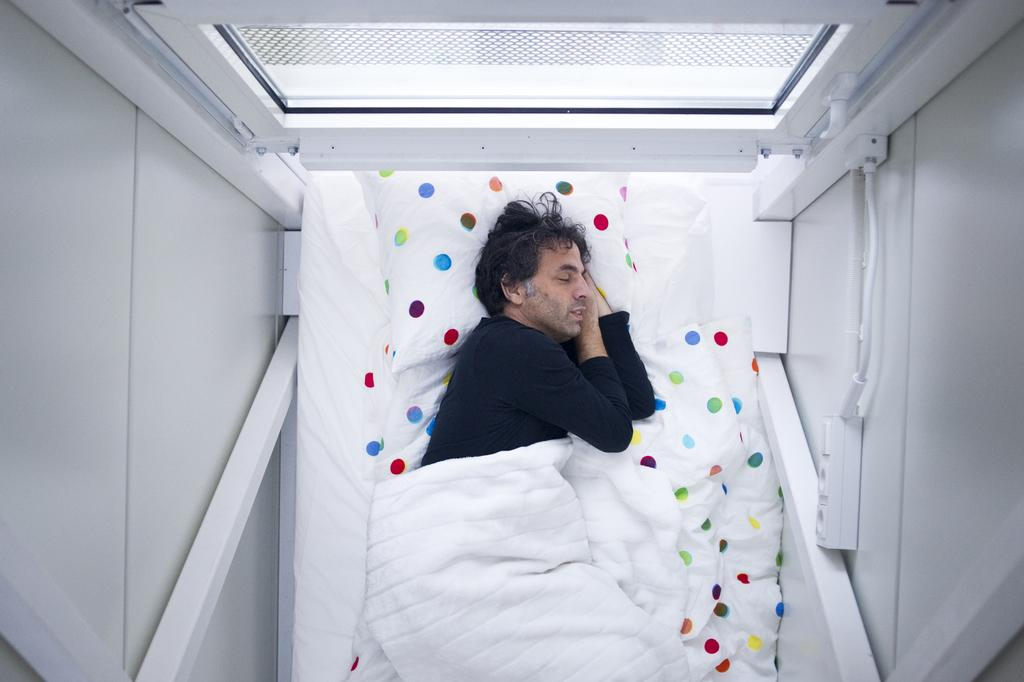Who is present in the image? There is a man in the image. What is the man doing in the image? The man is sleeping on a bed. What is covering the bed in the image? There is a bed sheet on the bed. What is supporting the man's head while he sleeps? There is a pillow on the bed. What can be seen in the background of the image? There is a window in the background of the image. What type of hand can be seen holding a book in the image? There is no hand or book present in the image; it features a man sleeping on a bed. 